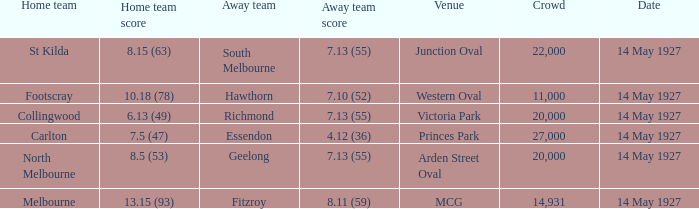12 (36)? Essendon. 